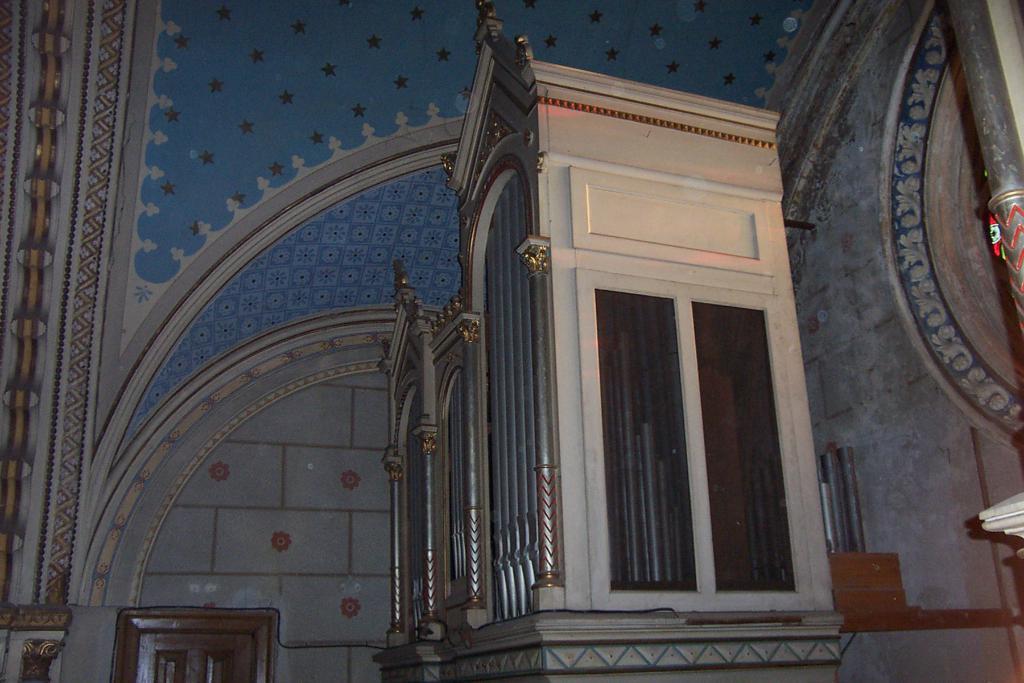Can you describe this image briefly? In this picture I can see the wooden room which is placed near to the wall. In the bottom left there is a door. On the right I can see the pillar. 